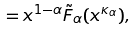Convert formula to latex. <formula><loc_0><loc_0><loc_500><loc_500>= x ^ { 1 - \alpha } \tilde { F } _ { \alpha } ( x ^ { \kappa _ { \alpha } } ) ,</formula> 